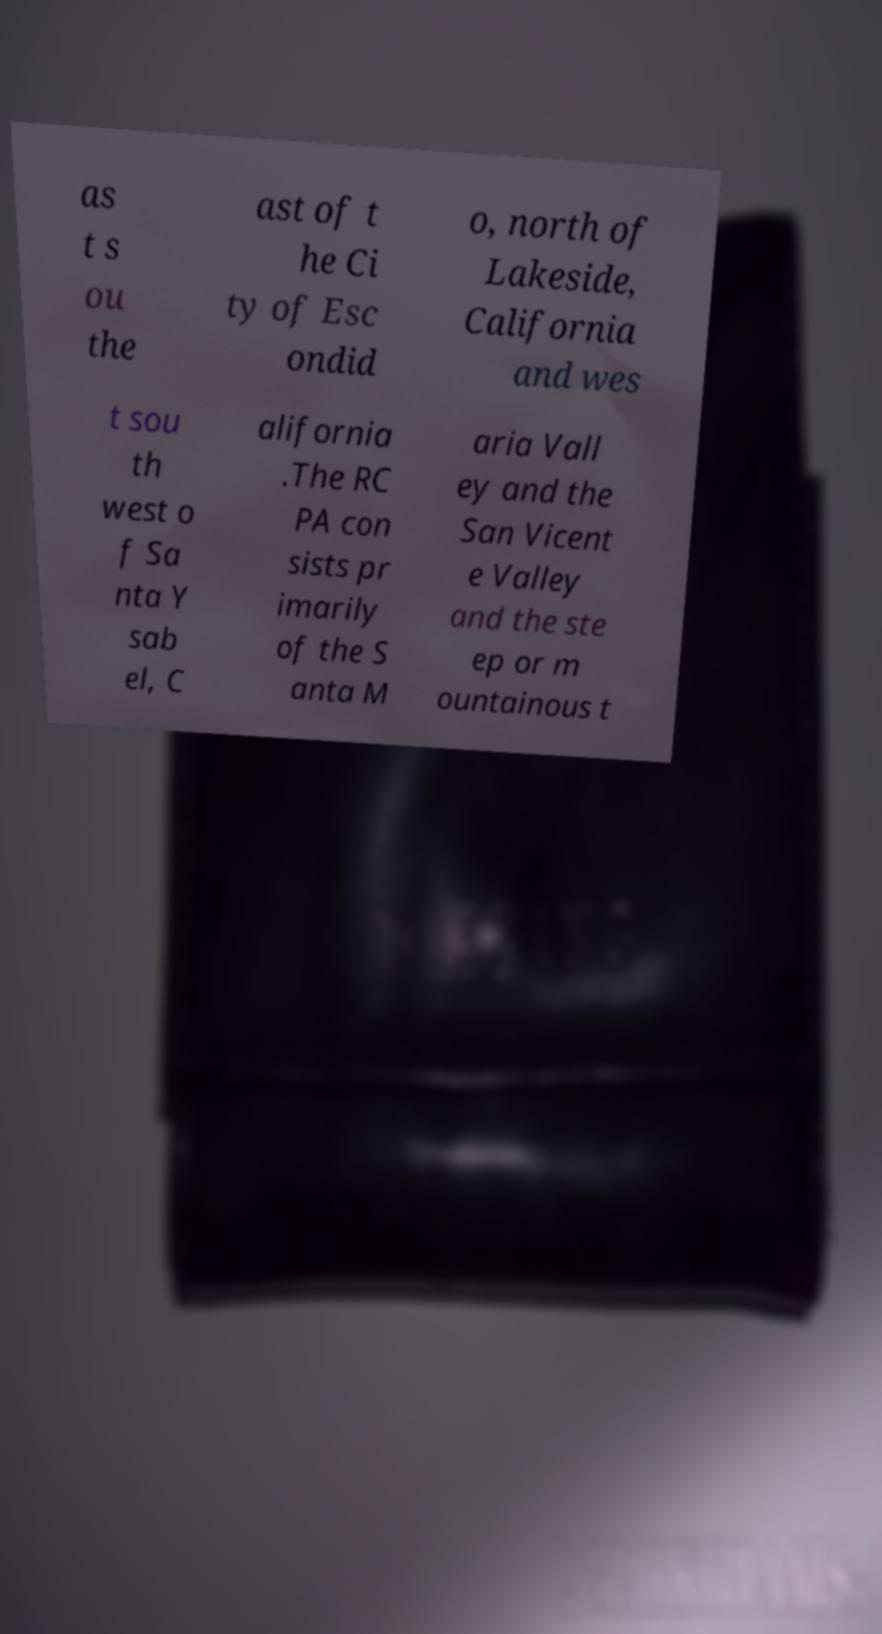Please identify and transcribe the text found in this image. as t s ou the ast of t he Ci ty of Esc ondid o, north of Lakeside, California and wes t sou th west o f Sa nta Y sab el, C alifornia .The RC PA con sists pr imarily of the S anta M aria Vall ey and the San Vicent e Valley and the ste ep or m ountainous t 